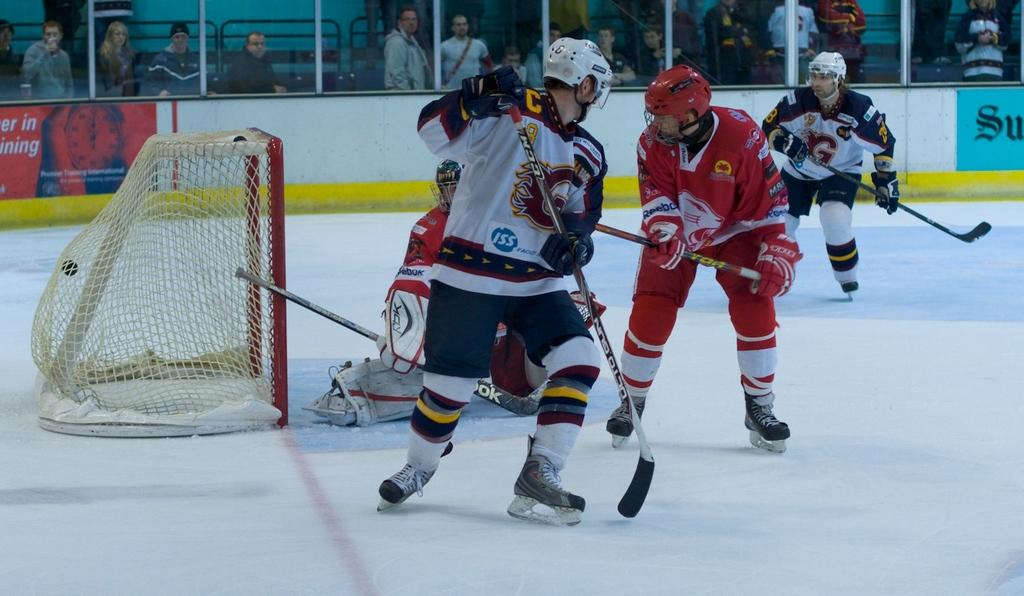What sport are the people playing in the image? The people are playing ice hockey in the image. What is located on the left side of the image? There is a net on the left side of the image. Can you describe the people in the background of the image? There are people standing in the background of the image. What can be seen in the background of the image besides the people? There is a board visible in the background of the image. What type of button can be seen on the ice hockey player's uniform in the image? There is no button visible on the ice hockey players' uniforms in the image. What time of day is it in the image, considering the presence of the afternoon sun? The image does not provide any information about the time of day, and there is no mention of the sun in the image. 